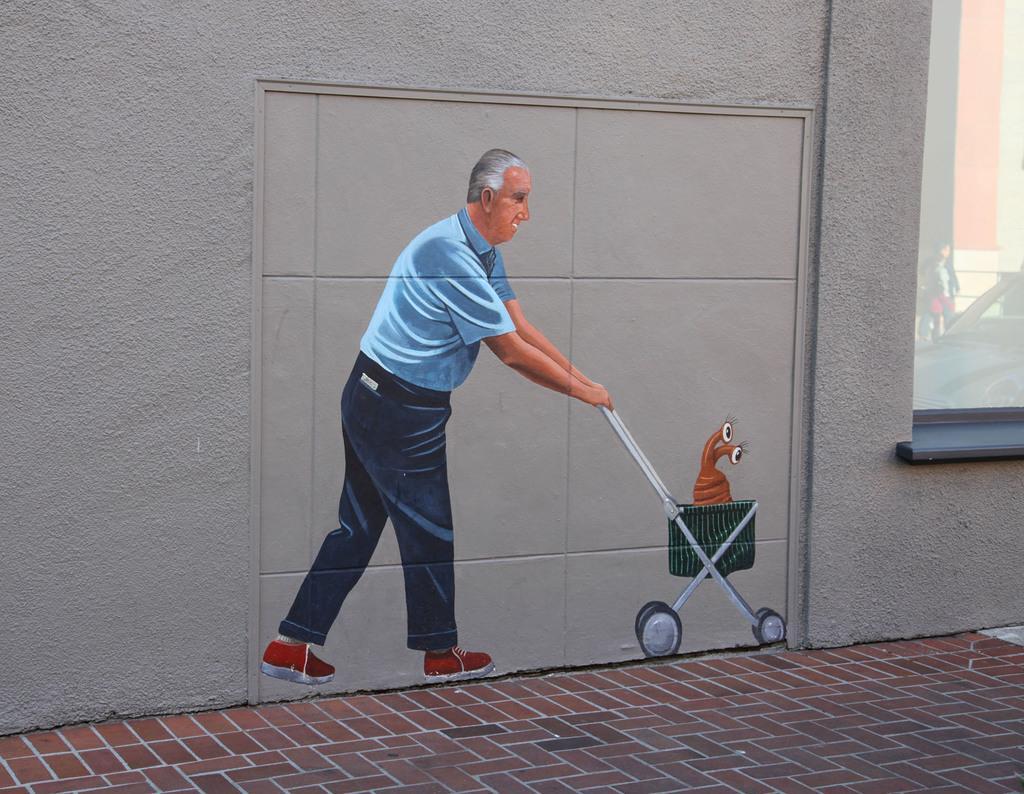How would you summarize this image in a sentence or two? In this image we can see there is an art of a person holding a trolley, in the trolley there is an insect on the wall of a building. In front of the building there is a path. 